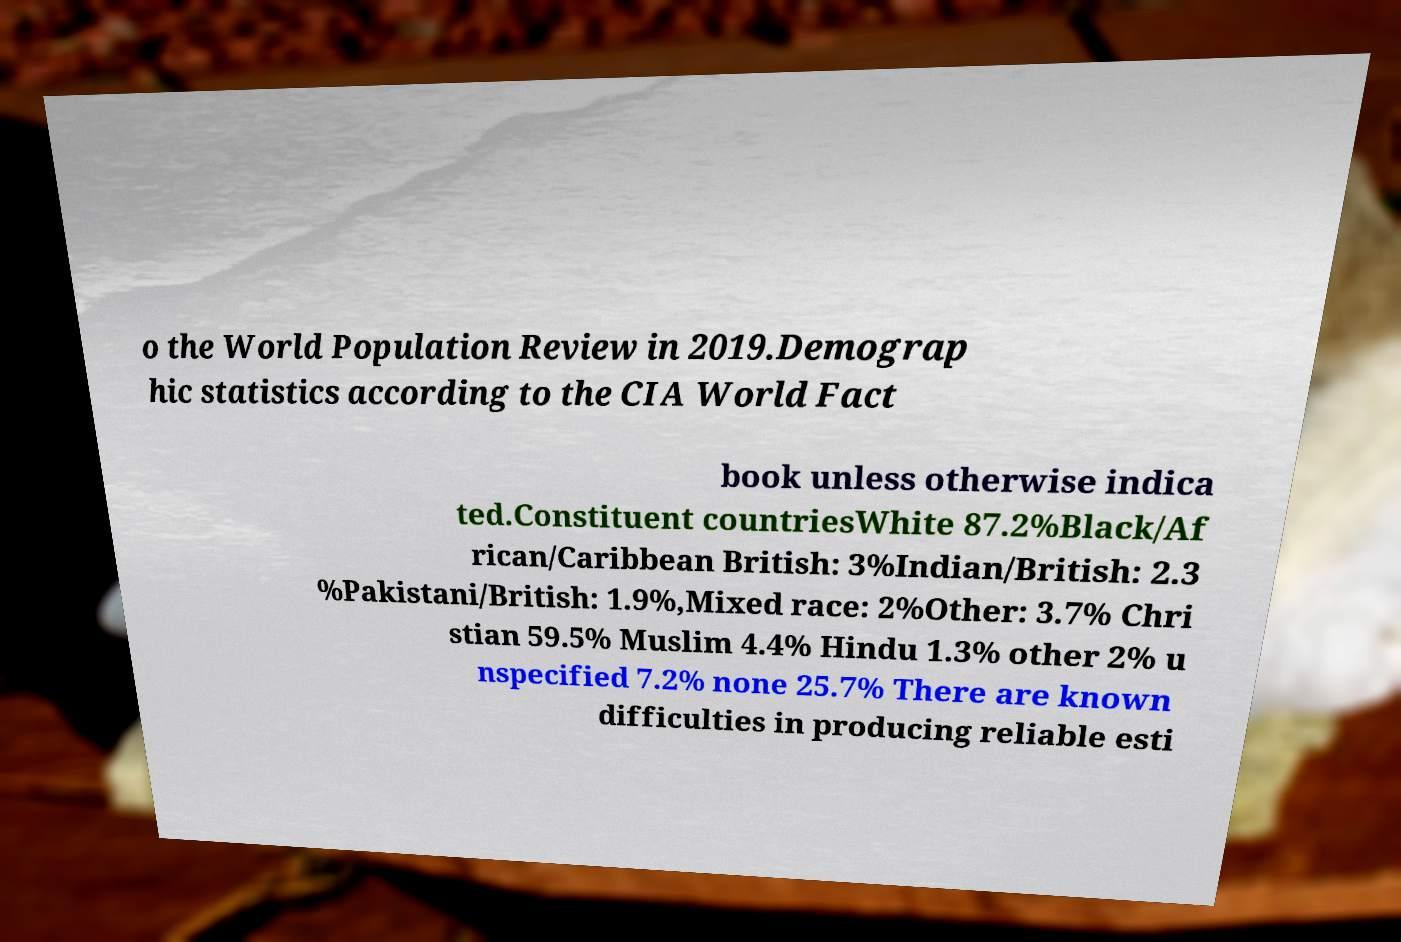Can you accurately transcribe the text from the provided image for me? o the World Population Review in 2019.Demograp hic statistics according to the CIA World Fact book unless otherwise indica ted.Constituent countriesWhite 87.2%Black/Af rican/Caribbean British: 3%Indian/British: 2.3 %Pakistani/British: 1.9%,Mixed race: 2%Other: 3.7% Chri stian 59.5% Muslim 4.4% Hindu 1.3% other 2% u nspecified 7.2% none 25.7% There are known difficulties in producing reliable esti 